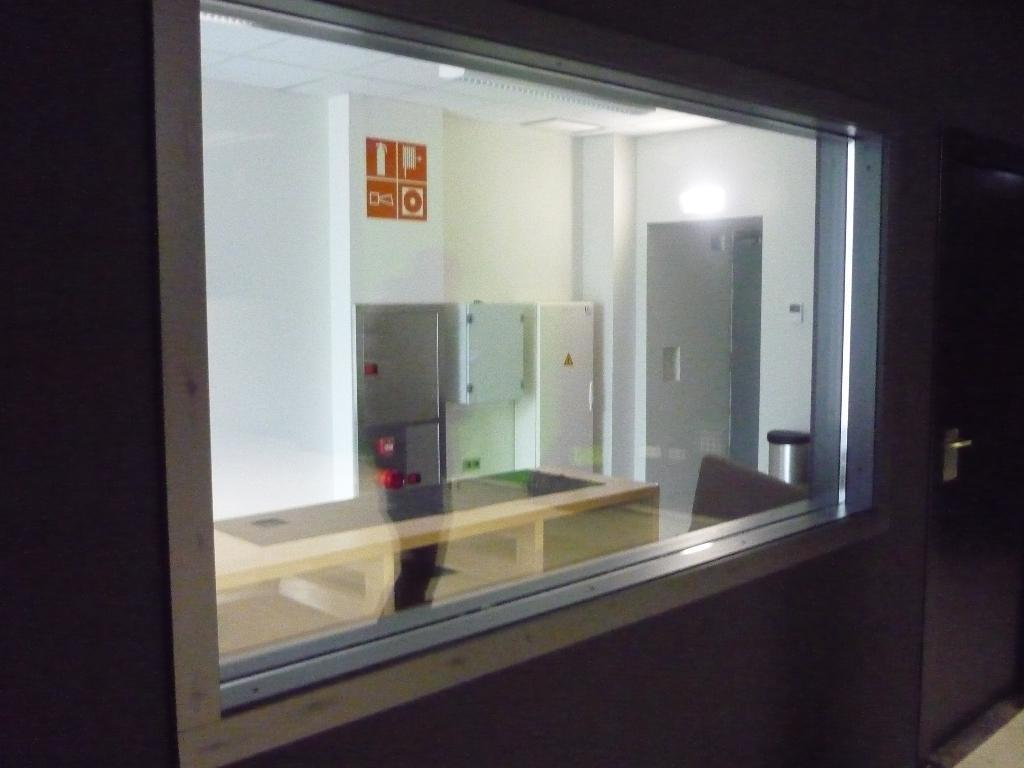What type of wall is in the middle of the image? There is a glass wall in the middle of the image. Where is the light located in relation to the glass wall? The light is on the right side of the glass wall. What can be seen inside the glass wall? There is a light inside the glass wall. What type of curve can be seen in the image? There is no curve present in the image; it features a glass wall with a light inside. 